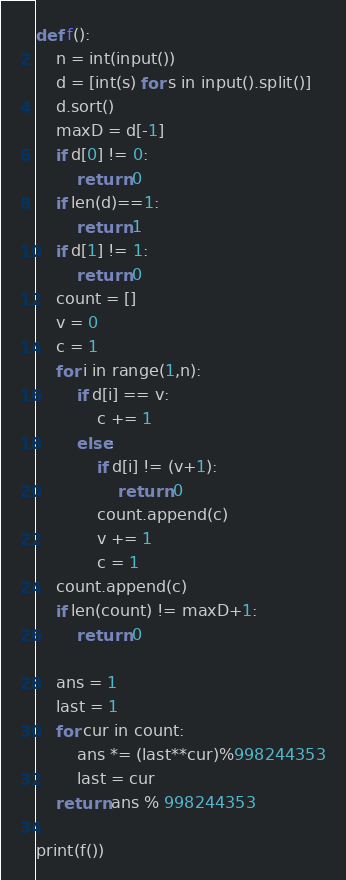Convert code to text. <code><loc_0><loc_0><loc_500><loc_500><_Python_>def f():
    n = int(input())
    d = [int(s) for s in input().split()]
    d.sort()
    maxD = d[-1]
    if d[0] != 0:
        return 0
    if len(d)==1:
        return 1
    if d[1] != 1:
        return 0
    count = []
    v = 0
    c = 1
    for i in range(1,n):
        if d[i] == v:
            c += 1
        else:
            if d[i] != (v+1):
                return 0
            count.append(c)
            v += 1
            c = 1
    count.append(c)
    if len(count) != maxD+1:
        return 0

    ans = 1
    last = 1
    for cur in count:
        ans *= (last**cur)%998244353
        last = cur
    return ans % 998244353

print(f())
</code> 